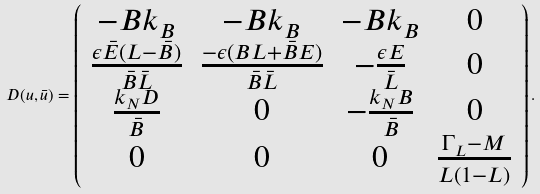<formula> <loc_0><loc_0><loc_500><loc_500>D ( u , \bar { u } ) = \left ( \begin{array} { c c c c } - B k _ { B } & - B k _ { B } & - B k _ { B } & 0 \\ \frac { \epsilon \bar { E } ( L - \bar { B } ) } { \bar { B } \bar { L } } & \frac { - \epsilon ( B L + \bar { B } E ) } { \bar { B } \bar { L } } & - \frac { \epsilon E } { \bar { L } } & 0 \\ \frac { k _ { N } D } { \bar { B } } & 0 & - \frac { k _ { N } B } { \bar { B } } & 0 \\ 0 & 0 & 0 & \frac { \Gamma _ { L } - M } { L ( 1 - L ) } \end{array} \right ) .</formula> 